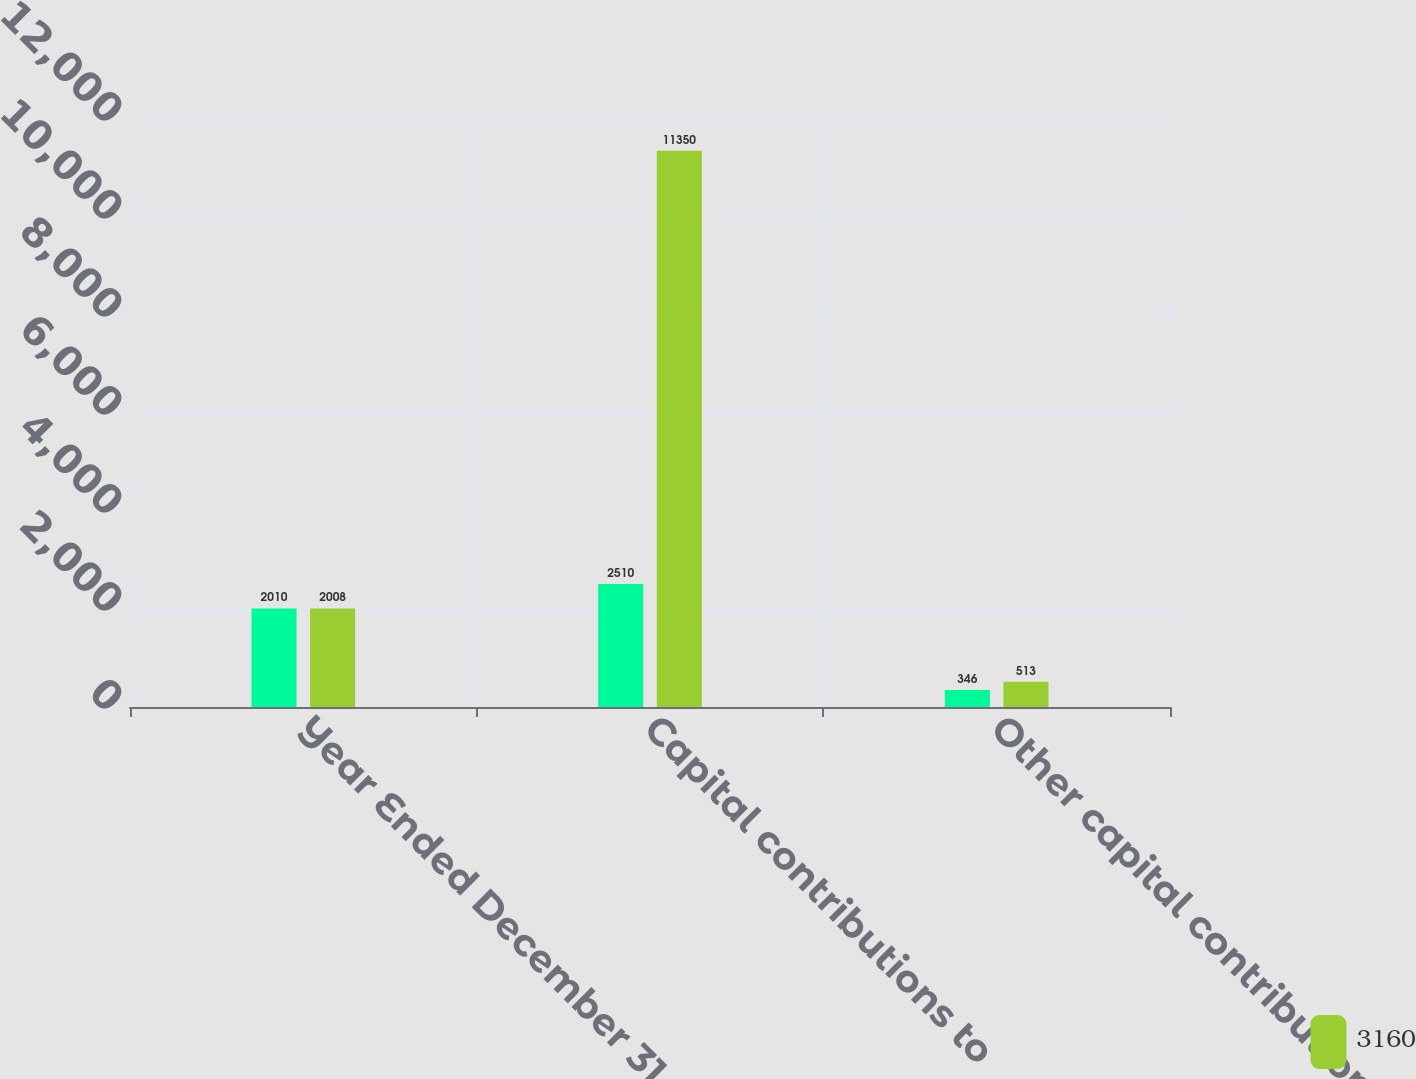<chart> <loc_0><loc_0><loc_500><loc_500><stacked_bar_chart><ecel><fcel>Year Ended December 31 (in<fcel>Capital contributions to<fcel>Other capital contributions -<nl><fcel>nan<fcel>2010<fcel>2510<fcel>346<nl><fcel>3160<fcel>2008<fcel>11350<fcel>513<nl></chart> 